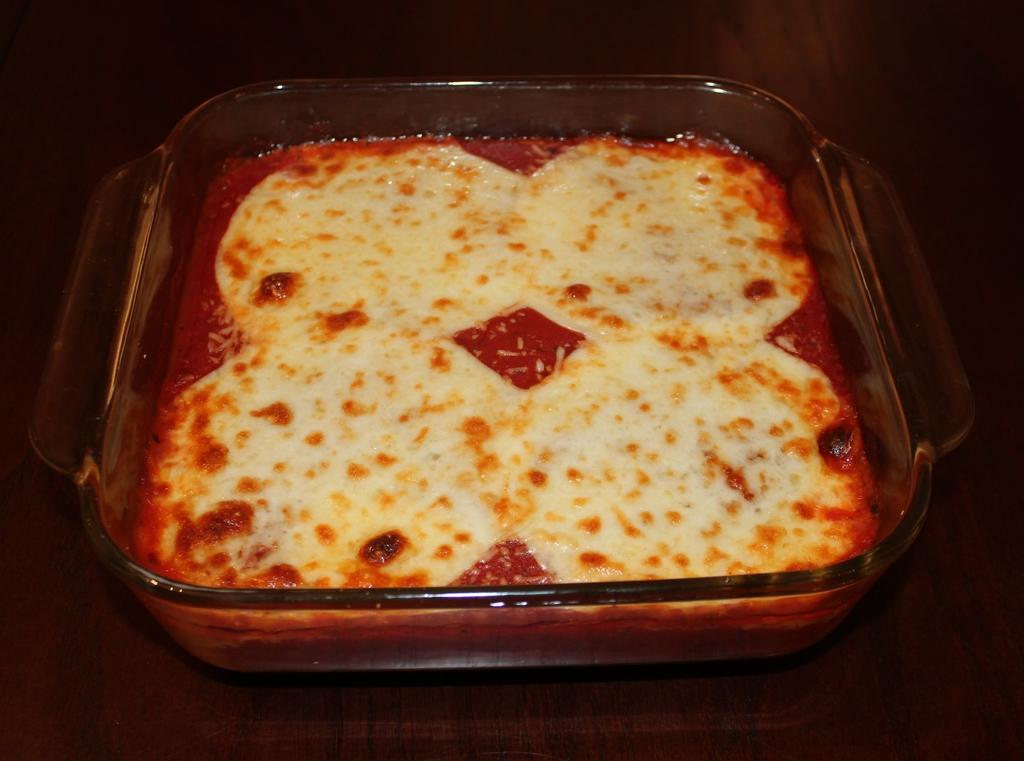What is in the bowl that is visible in the image? There is a bowl with food in the image. Where is the bowl located in the image? The bowl is placed on a surface in the image. What type of lamp is illuminating the food in the bowl? There is no lamp present in the image, and the food is not being illuminated by any light source. 